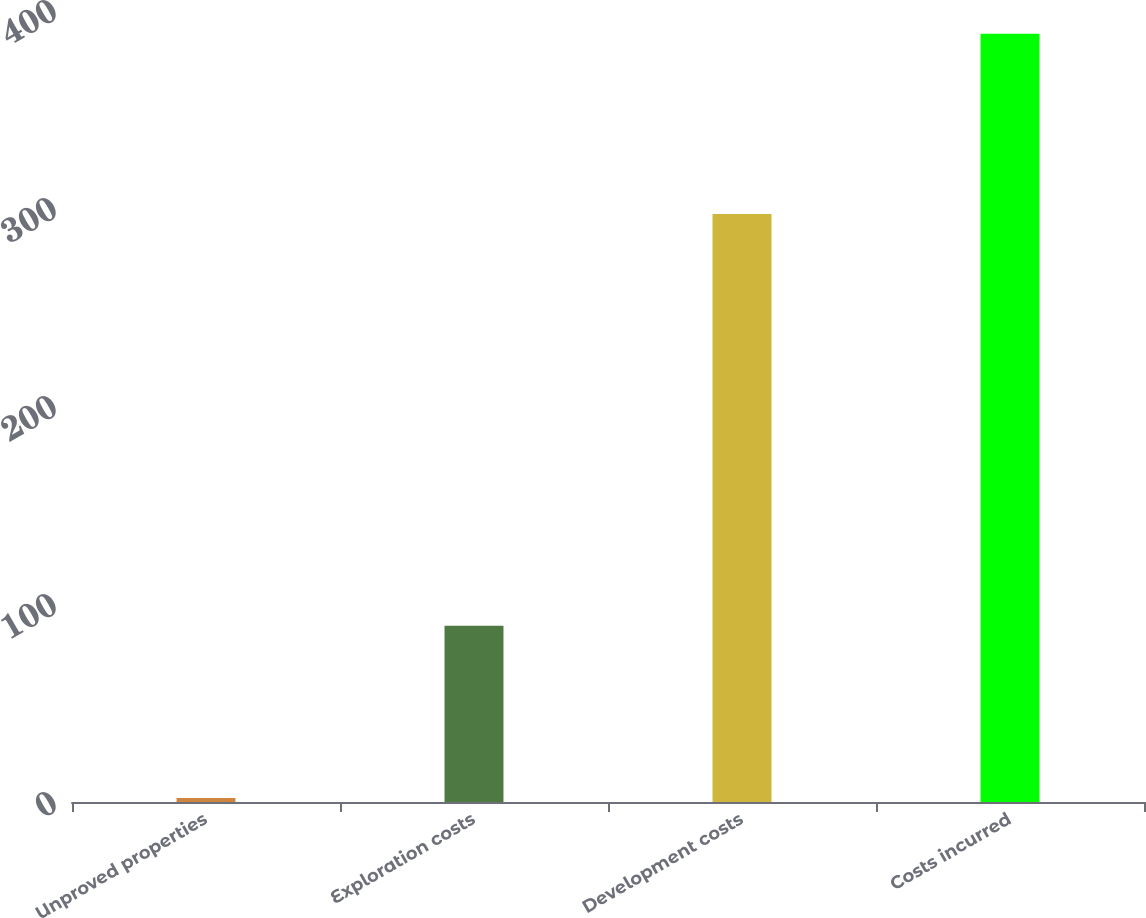Convert chart to OTSL. <chart><loc_0><loc_0><loc_500><loc_500><bar_chart><fcel>Unproved properties<fcel>Exploration costs<fcel>Development costs<fcel>Costs incurred<nl><fcel>2<fcel>89<fcel>297<fcel>388<nl></chart> 